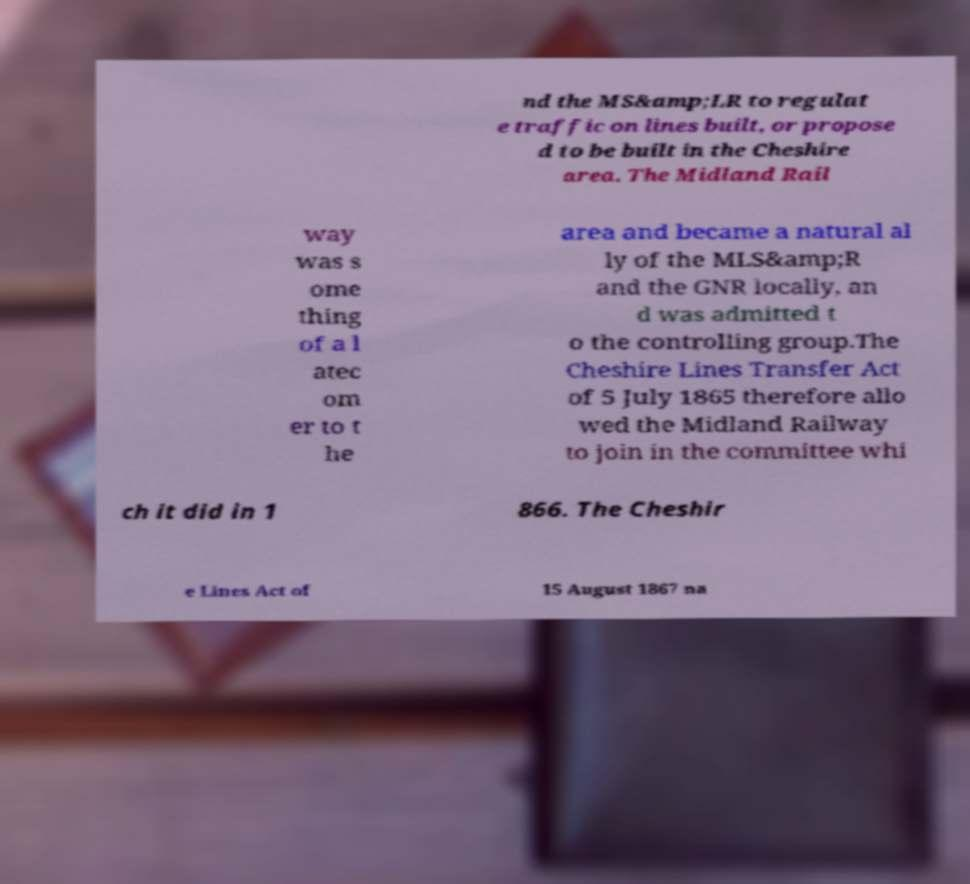Can you read and provide the text displayed in the image?This photo seems to have some interesting text. Can you extract and type it out for me? nd the MS&amp;LR to regulat e traffic on lines built, or propose d to be built in the Cheshire area. The Midland Rail way was s ome thing of a l atec om er to t he area and became a natural al ly of the MLS&amp;R and the GNR locally, an d was admitted t o the controlling group.The Cheshire Lines Transfer Act of 5 July 1865 therefore allo wed the Midland Railway to join in the committee whi ch it did in 1 866. The Cheshir e Lines Act of 15 August 1867 na 